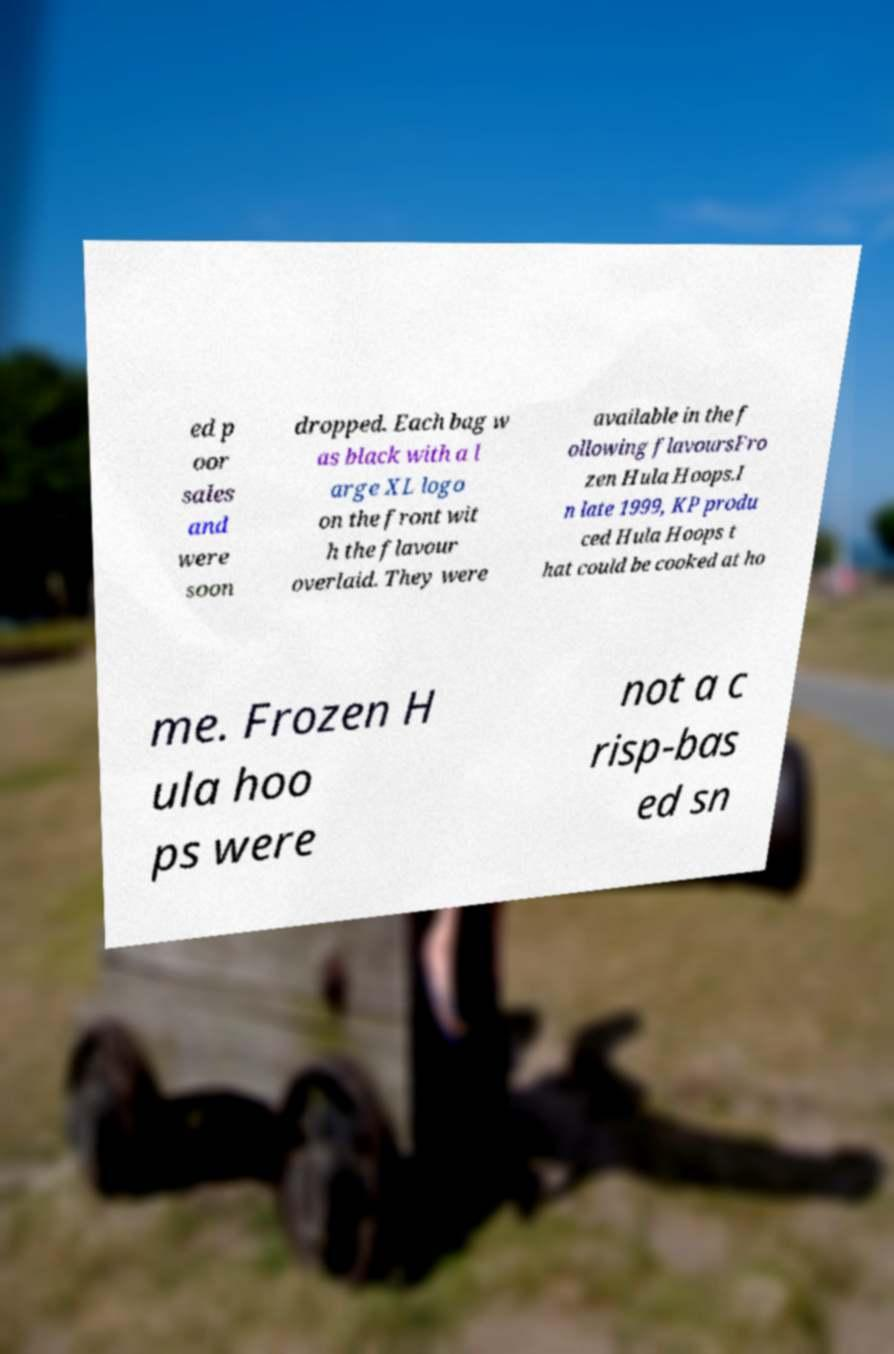Could you extract and type out the text from this image? ed p oor sales and were soon dropped. Each bag w as black with a l arge XL logo on the front wit h the flavour overlaid. They were available in the f ollowing flavoursFro zen Hula Hoops.I n late 1999, KP produ ced Hula Hoops t hat could be cooked at ho me. Frozen H ula hoo ps were not a c risp-bas ed sn 